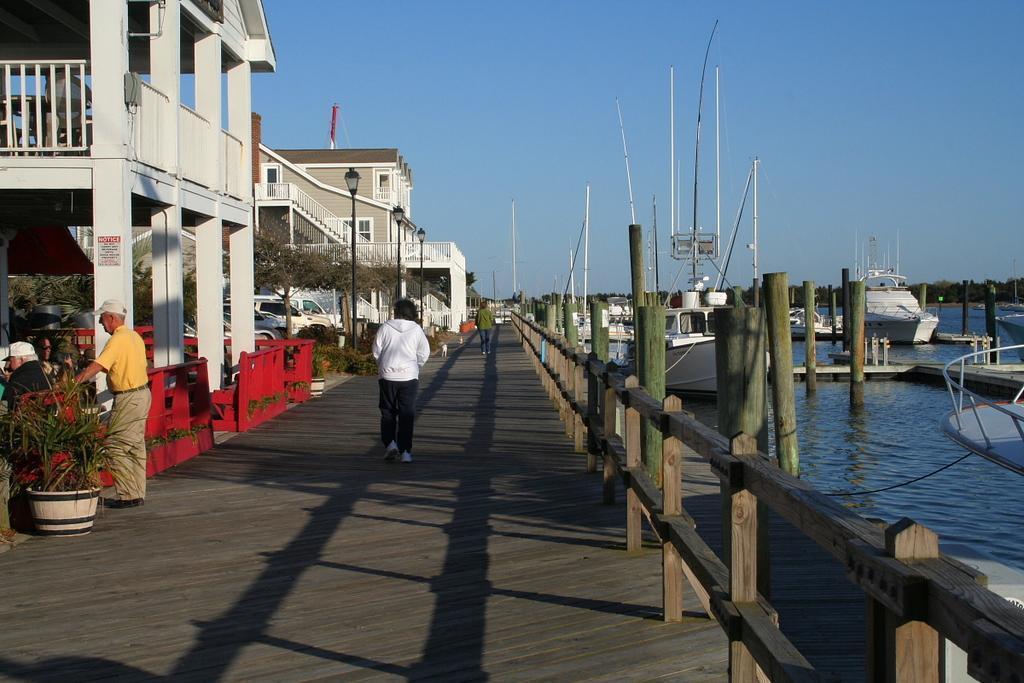How would you summarize this image in a sentence or two? In this picture there are people and we can see wooden fence, red color objects, plants, pots and board. We can see poles, pillars, wooden poles, boats, above the water, trees, lights, vehicles and buildings. In the background of the image we can see trees and sky. 